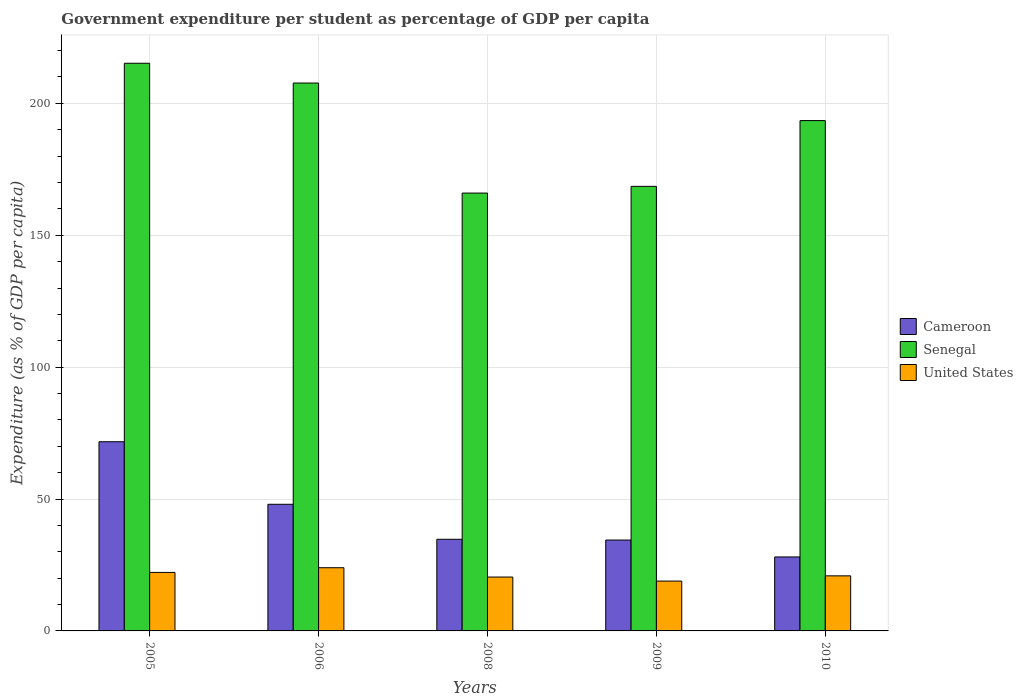How many groups of bars are there?
Offer a terse response. 5. Are the number of bars on each tick of the X-axis equal?
Keep it short and to the point. Yes. What is the label of the 1st group of bars from the left?
Keep it short and to the point. 2005. In how many cases, is the number of bars for a given year not equal to the number of legend labels?
Your answer should be compact. 0. What is the percentage of expenditure per student in Senegal in 2010?
Keep it short and to the point. 193.48. Across all years, what is the maximum percentage of expenditure per student in Senegal?
Provide a short and direct response. 215.21. Across all years, what is the minimum percentage of expenditure per student in United States?
Offer a very short reply. 18.89. In which year was the percentage of expenditure per student in United States maximum?
Your answer should be very brief. 2006. In which year was the percentage of expenditure per student in Senegal minimum?
Your response must be concise. 2008. What is the total percentage of expenditure per student in United States in the graph?
Offer a very short reply. 106.34. What is the difference between the percentage of expenditure per student in United States in 2009 and that in 2010?
Offer a very short reply. -1.99. What is the difference between the percentage of expenditure per student in Cameroon in 2009 and the percentage of expenditure per student in Senegal in 2006?
Make the answer very short. -173.26. What is the average percentage of expenditure per student in United States per year?
Your answer should be very brief. 21.27. In the year 2009, what is the difference between the percentage of expenditure per student in Senegal and percentage of expenditure per student in United States?
Keep it short and to the point. 149.65. What is the ratio of the percentage of expenditure per student in Senegal in 2006 to that in 2010?
Ensure brevity in your answer.  1.07. Is the difference between the percentage of expenditure per student in Senegal in 2005 and 2009 greater than the difference between the percentage of expenditure per student in United States in 2005 and 2009?
Your answer should be compact. Yes. What is the difference between the highest and the second highest percentage of expenditure per student in Cameroon?
Your response must be concise. 23.71. What is the difference between the highest and the lowest percentage of expenditure per student in Cameroon?
Your response must be concise. 43.67. In how many years, is the percentage of expenditure per student in United States greater than the average percentage of expenditure per student in United States taken over all years?
Provide a succinct answer. 2. Is the sum of the percentage of expenditure per student in Cameroon in 2008 and 2009 greater than the maximum percentage of expenditure per student in Senegal across all years?
Give a very brief answer. No. What does the 1st bar from the left in 2005 represents?
Your answer should be very brief. Cameroon. What does the 1st bar from the right in 2009 represents?
Your answer should be compact. United States. Is it the case that in every year, the sum of the percentage of expenditure per student in Senegal and percentage of expenditure per student in United States is greater than the percentage of expenditure per student in Cameroon?
Give a very brief answer. Yes. How many bars are there?
Your answer should be compact. 15. How many years are there in the graph?
Offer a very short reply. 5. Where does the legend appear in the graph?
Your answer should be very brief. Center right. What is the title of the graph?
Provide a succinct answer. Government expenditure per student as percentage of GDP per capita. What is the label or title of the X-axis?
Your answer should be very brief. Years. What is the label or title of the Y-axis?
Keep it short and to the point. Expenditure (as % of GDP per capita). What is the Expenditure (as % of GDP per capita) in Cameroon in 2005?
Offer a very short reply. 71.72. What is the Expenditure (as % of GDP per capita) in Senegal in 2005?
Keep it short and to the point. 215.21. What is the Expenditure (as % of GDP per capita) of United States in 2005?
Give a very brief answer. 22.18. What is the Expenditure (as % of GDP per capita) in Cameroon in 2006?
Offer a very short reply. 48.01. What is the Expenditure (as % of GDP per capita) of Senegal in 2006?
Offer a terse response. 207.71. What is the Expenditure (as % of GDP per capita) of United States in 2006?
Make the answer very short. 23.96. What is the Expenditure (as % of GDP per capita) of Cameroon in 2008?
Your answer should be very brief. 34.74. What is the Expenditure (as % of GDP per capita) of Senegal in 2008?
Your answer should be very brief. 166. What is the Expenditure (as % of GDP per capita) of United States in 2008?
Your answer should be compact. 20.43. What is the Expenditure (as % of GDP per capita) of Cameroon in 2009?
Keep it short and to the point. 34.46. What is the Expenditure (as % of GDP per capita) in Senegal in 2009?
Offer a very short reply. 168.54. What is the Expenditure (as % of GDP per capita) in United States in 2009?
Offer a very short reply. 18.89. What is the Expenditure (as % of GDP per capita) of Cameroon in 2010?
Provide a short and direct response. 28.04. What is the Expenditure (as % of GDP per capita) in Senegal in 2010?
Offer a terse response. 193.48. What is the Expenditure (as % of GDP per capita) of United States in 2010?
Ensure brevity in your answer.  20.88. Across all years, what is the maximum Expenditure (as % of GDP per capita) in Cameroon?
Your answer should be very brief. 71.72. Across all years, what is the maximum Expenditure (as % of GDP per capita) in Senegal?
Your response must be concise. 215.21. Across all years, what is the maximum Expenditure (as % of GDP per capita) in United States?
Offer a terse response. 23.96. Across all years, what is the minimum Expenditure (as % of GDP per capita) of Cameroon?
Your answer should be compact. 28.04. Across all years, what is the minimum Expenditure (as % of GDP per capita) of Senegal?
Provide a short and direct response. 166. Across all years, what is the minimum Expenditure (as % of GDP per capita) in United States?
Your answer should be very brief. 18.89. What is the total Expenditure (as % of GDP per capita) of Cameroon in the graph?
Your answer should be compact. 216.96. What is the total Expenditure (as % of GDP per capita) of Senegal in the graph?
Offer a terse response. 950.94. What is the total Expenditure (as % of GDP per capita) of United States in the graph?
Make the answer very short. 106.34. What is the difference between the Expenditure (as % of GDP per capita) of Cameroon in 2005 and that in 2006?
Offer a terse response. 23.71. What is the difference between the Expenditure (as % of GDP per capita) of Senegal in 2005 and that in 2006?
Your response must be concise. 7.5. What is the difference between the Expenditure (as % of GDP per capita) in United States in 2005 and that in 2006?
Give a very brief answer. -1.78. What is the difference between the Expenditure (as % of GDP per capita) of Cameroon in 2005 and that in 2008?
Your answer should be very brief. 36.98. What is the difference between the Expenditure (as % of GDP per capita) in Senegal in 2005 and that in 2008?
Your response must be concise. 49.21. What is the difference between the Expenditure (as % of GDP per capita) of United States in 2005 and that in 2008?
Provide a short and direct response. 1.76. What is the difference between the Expenditure (as % of GDP per capita) of Cameroon in 2005 and that in 2009?
Your answer should be compact. 37.26. What is the difference between the Expenditure (as % of GDP per capita) in Senegal in 2005 and that in 2009?
Ensure brevity in your answer.  46.67. What is the difference between the Expenditure (as % of GDP per capita) in United States in 2005 and that in 2009?
Offer a very short reply. 3.29. What is the difference between the Expenditure (as % of GDP per capita) in Cameroon in 2005 and that in 2010?
Give a very brief answer. 43.67. What is the difference between the Expenditure (as % of GDP per capita) of Senegal in 2005 and that in 2010?
Keep it short and to the point. 21.73. What is the difference between the Expenditure (as % of GDP per capita) of United States in 2005 and that in 2010?
Provide a succinct answer. 1.3. What is the difference between the Expenditure (as % of GDP per capita) of Cameroon in 2006 and that in 2008?
Make the answer very short. 13.27. What is the difference between the Expenditure (as % of GDP per capita) in Senegal in 2006 and that in 2008?
Keep it short and to the point. 41.72. What is the difference between the Expenditure (as % of GDP per capita) in United States in 2006 and that in 2008?
Give a very brief answer. 3.53. What is the difference between the Expenditure (as % of GDP per capita) of Cameroon in 2006 and that in 2009?
Provide a short and direct response. 13.55. What is the difference between the Expenditure (as % of GDP per capita) of Senegal in 2006 and that in 2009?
Ensure brevity in your answer.  39.17. What is the difference between the Expenditure (as % of GDP per capita) in United States in 2006 and that in 2009?
Provide a short and direct response. 5.07. What is the difference between the Expenditure (as % of GDP per capita) in Cameroon in 2006 and that in 2010?
Give a very brief answer. 19.96. What is the difference between the Expenditure (as % of GDP per capita) of Senegal in 2006 and that in 2010?
Offer a terse response. 14.24. What is the difference between the Expenditure (as % of GDP per capita) in United States in 2006 and that in 2010?
Provide a succinct answer. 3.08. What is the difference between the Expenditure (as % of GDP per capita) of Cameroon in 2008 and that in 2009?
Make the answer very short. 0.28. What is the difference between the Expenditure (as % of GDP per capita) of Senegal in 2008 and that in 2009?
Provide a succinct answer. -2.55. What is the difference between the Expenditure (as % of GDP per capita) of United States in 2008 and that in 2009?
Your answer should be compact. 1.53. What is the difference between the Expenditure (as % of GDP per capita) in Cameroon in 2008 and that in 2010?
Your response must be concise. 6.69. What is the difference between the Expenditure (as % of GDP per capita) of Senegal in 2008 and that in 2010?
Your answer should be very brief. -27.48. What is the difference between the Expenditure (as % of GDP per capita) in United States in 2008 and that in 2010?
Offer a terse response. -0.45. What is the difference between the Expenditure (as % of GDP per capita) in Cameroon in 2009 and that in 2010?
Keep it short and to the point. 6.41. What is the difference between the Expenditure (as % of GDP per capita) in Senegal in 2009 and that in 2010?
Keep it short and to the point. -24.93. What is the difference between the Expenditure (as % of GDP per capita) in United States in 2009 and that in 2010?
Provide a succinct answer. -1.99. What is the difference between the Expenditure (as % of GDP per capita) of Cameroon in 2005 and the Expenditure (as % of GDP per capita) of Senegal in 2006?
Keep it short and to the point. -135.99. What is the difference between the Expenditure (as % of GDP per capita) of Cameroon in 2005 and the Expenditure (as % of GDP per capita) of United States in 2006?
Give a very brief answer. 47.76. What is the difference between the Expenditure (as % of GDP per capita) in Senegal in 2005 and the Expenditure (as % of GDP per capita) in United States in 2006?
Make the answer very short. 191.25. What is the difference between the Expenditure (as % of GDP per capita) of Cameroon in 2005 and the Expenditure (as % of GDP per capita) of Senegal in 2008?
Keep it short and to the point. -94.28. What is the difference between the Expenditure (as % of GDP per capita) of Cameroon in 2005 and the Expenditure (as % of GDP per capita) of United States in 2008?
Ensure brevity in your answer.  51.29. What is the difference between the Expenditure (as % of GDP per capita) in Senegal in 2005 and the Expenditure (as % of GDP per capita) in United States in 2008?
Offer a very short reply. 194.78. What is the difference between the Expenditure (as % of GDP per capita) in Cameroon in 2005 and the Expenditure (as % of GDP per capita) in Senegal in 2009?
Ensure brevity in your answer.  -96.82. What is the difference between the Expenditure (as % of GDP per capita) of Cameroon in 2005 and the Expenditure (as % of GDP per capita) of United States in 2009?
Provide a short and direct response. 52.83. What is the difference between the Expenditure (as % of GDP per capita) of Senegal in 2005 and the Expenditure (as % of GDP per capita) of United States in 2009?
Provide a succinct answer. 196.32. What is the difference between the Expenditure (as % of GDP per capita) in Cameroon in 2005 and the Expenditure (as % of GDP per capita) in Senegal in 2010?
Offer a terse response. -121.76. What is the difference between the Expenditure (as % of GDP per capita) of Cameroon in 2005 and the Expenditure (as % of GDP per capita) of United States in 2010?
Keep it short and to the point. 50.84. What is the difference between the Expenditure (as % of GDP per capita) of Senegal in 2005 and the Expenditure (as % of GDP per capita) of United States in 2010?
Your answer should be compact. 194.33. What is the difference between the Expenditure (as % of GDP per capita) in Cameroon in 2006 and the Expenditure (as % of GDP per capita) in Senegal in 2008?
Offer a terse response. -117.99. What is the difference between the Expenditure (as % of GDP per capita) of Cameroon in 2006 and the Expenditure (as % of GDP per capita) of United States in 2008?
Provide a succinct answer. 27.58. What is the difference between the Expenditure (as % of GDP per capita) in Senegal in 2006 and the Expenditure (as % of GDP per capita) in United States in 2008?
Keep it short and to the point. 187.29. What is the difference between the Expenditure (as % of GDP per capita) of Cameroon in 2006 and the Expenditure (as % of GDP per capita) of Senegal in 2009?
Make the answer very short. -120.54. What is the difference between the Expenditure (as % of GDP per capita) in Cameroon in 2006 and the Expenditure (as % of GDP per capita) in United States in 2009?
Your answer should be compact. 29.12. What is the difference between the Expenditure (as % of GDP per capita) of Senegal in 2006 and the Expenditure (as % of GDP per capita) of United States in 2009?
Your response must be concise. 188.82. What is the difference between the Expenditure (as % of GDP per capita) in Cameroon in 2006 and the Expenditure (as % of GDP per capita) in Senegal in 2010?
Give a very brief answer. -145.47. What is the difference between the Expenditure (as % of GDP per capita) in Cameroon in 2006 and the Expenditure (as % of GDP per capita) in United States in 2010?
Give a very brief answer. 27.13. What is the difference between the Expenditure (as % of GDP per capita) of Senegal in 2006 and the Expenditure (as % of GDP per capita) of United States in 2010?
Your response must be concise. 186.83. What is the difference between the Expenditure (as % of GDP per capita) in Cameroon in 2008 and the Expenditure (as % of GDP per capita) in Senegal in 2009?
Provide a succinct answer. -133.8. What is the difference between the Expenditure (as % of GDP per capita) of Cameroon in 2008 and the Expenditure (as % of GDP per capita) of United States in 2009?
Offer a terse response. 15.85. What is the difference between the Expenditure (as % of GDP per capita) in Senegal in 2008 and the Expenditure (as % of GDP per capita) in United States in 2009?
Keep it short and to the point. 147.11. What is the difference between the Expenditure (as % of GDP per capita) of Cameroon in 2008 and the Expenditure (as % of GDP per capita) of Senegal in 2010?
Ensure brevity in your answer.  -158.74. What is the difference between the Expenditure (as % of GDP per capita) of Cameroon in 2008 and the Expenditure (as % of GDP per capita) of United States in 2010?
Make the answer very short. 13.86. What is the difference between the Expenditure (as % of GDP per capita) in Senegal in 2008 and the Expenditure (as % of GDP per capita) in United States in 2010?
Offer a very short reply. 145.12. What is the difference between the Expenditure (as % of GDP per capita) in Cameroon in 2009 and the Expenditure (as % of GDP per capita) in Senegal in 2010?
Your answer should be compact. -159.02. What is the difference between the Expenditure (as % of GDP per capita) in Cameroon in 2009 and the Expenditure (as % of GDP per capita) in United States in 2010?
Offer a very short reply. 13.58. What is the difference between the Expenditure (as % of GDP per capita) of Senegal in 2009 and the Expenditure (as % of GDP per capita) of United States in 2010?
Give a very brief answer. 147.66. What is the average Expenditure (as % of GDP per capita) of Cameroon per year?
Your response must be concise. 43.39. What is the average Expenditure (as % of GDP per capita) of Senegal per year?
Give a very brief answer. 190.19. What is the average Expenditure (as % of GDP per capita) of United States per year?
Your answer should be compact. 21.27. In the year 2005, what is the difference between the Expenditure (as % of GDP per capita) of Cameroon and Expenditure (as % of GDP per capita) of Senegal?
Offer a very short reply. -143.49. In the year 2005, what is the difference between the Expenditure (as % of GDP per capita) of Cameroon and Expenditure (as % of GDP per capita) of United States?
Provide a succinct answer. 49.54. In the year 2005, what is the difference between the Expenditure (as % of GDP per capita) of Senegal and Expenditure (as % of GDP per capita) of United States?
Offer a terse response. 193.03. In the year 2006, what is the difference between the Expenditure (as % of GDP per capita) in Cameroon and Expenditure (as % of GDP per capita) in Senegal?
Keep it short and to the point. -159.71. In the year 2006, what is the difference between the Expenditure (as % of GDP per capita) of Cameroon and Expenditure (as % of GDP per capita) of United States?
Offer a very short reply. 24.05. In the year 2006, what is the difference between the Expenditure (as % of GDP per capita) of Senegal and Expenditure (as % of GDP per capita) of United States?
Give a very brief answer. 183.75. In the year 2008, what is the difference between the Expenditure (as % of GDP per capita) of Cameroon and Expenditure (as % of GDP per capita) of Senegal?
Make the answer very short. -131.26. In the year 2008, what is the difference between the Expenditure (as % of GDP per capita) of Cameroon and Expenditure (as % of GDP per capita) of United States?
Make the answer very short. 14.31. In the year 2008, what is the difference between the Expenditure (as % of GDP per capita) of Senegal and Expenditure (as % of GDP per capita) of United States?
Keep it short and to the point. 145.57. In the year 2009, what is the difference between the Expenditure (as % of GDP per capita) in Cameroon and Expenditure (as % of GDP per capita) in Senegal?
Provide a short and direct response. -134.09. In the year 2009, what is the difference between the Expenditure (as % of GDP per capita) in Cameroon and Expenditure (as % of GDP per capita) in United States?
Your answer should be compact. 15.56. In the year 2009, what is the difference between the Expenditure (as % of GDP per capita) of Senegal and Expenditure (as % of GDP per capita) of United States?
Ensure brevity in your answer.  149.65. In the year 2010, what is the difference between the Expenditure (as % of GDP per capita) in Cameroon and Expenditure (as % of GDP per capita) in Senegal?
Provide a short and direct response. -165.43. In the year 2010, what is the difference between the Expenditure (as % of GDP per capita) of Cameroon and Expenditure (as % of GDP per capita) of United States?
Ensure brevity in your answer.  7.16. In the year 2010, what is the difference between the Expenditure (as % of GDP per capita) in Senegal and Expenditure (as % of GDP per capita) in United States?
Your answer should be compact. 172.6. What is the ratio of the Expenditure (as % of GDP per capita) of Cameroon in 2005 to that in 2006?
Provide a short and direct response. 1.49. What is the ratio of the Expenditure (as % of GDP per capita) of Senegal in 2005 to that in 2006?
Ensure brevity in your answer.  1.04. What is the ratio of the Expenditure (as % of GDP per capita) of United States in 2005 to that in 2006?
Your answer should be compact. 0.93. What is the ratio of the Expenditure (as % of GDP per capita) of Cameroon in 2005 to that in 2008?
Ensure brevity in your answer.  2.06. What is the ratio of the Expenditure (as % of GDP per capita) in Senegal in 2005 to that in 2008?
Offer a terse response. 1.3. What is the ratio of the Expenditure (as % of GDP per capita) in United States in 2005 to that in 2008?
Offer a very short reply. 1.09. What is the ratio of the Expenditure (as % of GDP per capita) of Cameroon in 2005 to that in 2009?
Offer a very short reply. 2.08. What is the ratio of the Expenditure (as % of GDP per capita) of Senegal in 2005 to that in 2009?
Make the answer very short. 1.28. What is the ratio of the Expenditure (as % of GDP per capita) in United States in 2005 to that in 2009?
Make the answer very short. 1.17. What is the ratio of the Expenditure (as % of GDP per capita) of Cameroon in 2005 to that in 2010?
Your response must be concise. 2.56. What is the ratio of the Expenditure (as % of GDP per capita) of Senegal in 2005 to that in 2010?
Keep it short and to the point. 1.11. What is the ratio of the Expenditure (as % of GDP per capita) of United States in 2005 to that in 2010?
Your answer should be very brief. 1.06. What is the ratio of the Expenditure (as % of GDP per capita) of Cameroon in 2006 to that in 2008?
Offer a very short reply. 1.38. What is the ratio of the Expenditure (as % of GDP per capita) in Senegal in 2006 to that in 2008?
Your answer should be compact. 1.25. What is the ratio of the Expenditure (as % of GDP per capita) of United States in 2006 to that in 2008?
Keep it short and to the point. 1.17. What is the ratio of the Expenditure (as % of GDP per capita) of Cameroon in 2006 to that in 2009?
Ensure brevity in your answer.  1.39. What is the ratio of the Expenditure (as % of GDP per capita) of Senegal in 2006 to that in 2009?
Your response must be concise. 1.23. What is the ratio of the Expenditure (as % of GDP per capita) in United States in 2006 to that in 2009?
Your response must be concise. 1.27. What is the ratio of the Expenditure (as % of GDP per capita) in Cameroon in 2006 to that in 2010?
Your response must be concise. 1.71. What is the ratio of the Expenditure (as % of GDP per capita) of Senegal in 2006 to that in 2010?
Make the answer very short. 1.07. What is the ratio of the Expenditure (as % of GDP per capita) in United States in 2006 to that in 2010?
Provide a short and direct response. 1.15. What is the ratio of the Expenditure (as % of GDP per capita) in Cameroon in 2008 to that in 2009?
Keep it short and to the point. 1.01. What is the ratio of the Expenditure (as % of GDP per capita) in Senegal in 2008 to that in 2009?
Offer a very short reply. 0.98. What is the ratio of the Expenditure (as % of GDP per capita) in United States in 2008 to that in 2009?
Offer a very short reply. 1.08. What is the ratio of the Expenditure (as % of GDP per capita) of Cameroon in 2008 to that in 2010?
Make the answer very short. 1.24. What is the ratio of the Expenditure (as % of GDP per capita) of Senegal in 2008 to that in 2010?
Give a very brief answer. 0.86. What is the ratio of the Expenditure (as % of GDP per capita) in United States in 2008 to that in 2010?
Your response must be concise. 0.98. What is the ratio of the Expenditure (as % of GDP per capita) of Cameroon in 2009 to that in 2010?
Keep it short and to the point. 1.23. What is the ratio of the Expenditure (as % of GDP per capita) in Senegal in 2009 to that in 2010?
Provide a short and direct response. 0.87. What is the ratio of the Expenditure (as % of GDP per capita) of United States in 2009 to that in 2010?
Make the answer very short. 0.9. What is the difference between the highest and the second highest Expenditure (as % of GDP per capita) in Cameroon?
Offer a very short reply. 23.71. What is the difference between the highest and the second highest Expenditure (as % of GDP per capita) of Senegal?
Ensure brevity in your answer.  7.5. What is the difference between the highest and the second highest Expenditure (as % of GDP per capita) of United States?
Provide a succinct answer. 1.78. What is the difference between the highest and the lowest Expenditure (as % of GDP per capita) of Cameroon?
Provide a short and direct response. 43.67. What is the difference between the highest and the lowest Expenditure (as % of GDP per capita) in Senegal?
Make the answer very short. 49.21. What is the difference between the highest and the lowest Expenditure (as % of GDP per capita) of United States?
Keep it short and to the point. 5.07. 